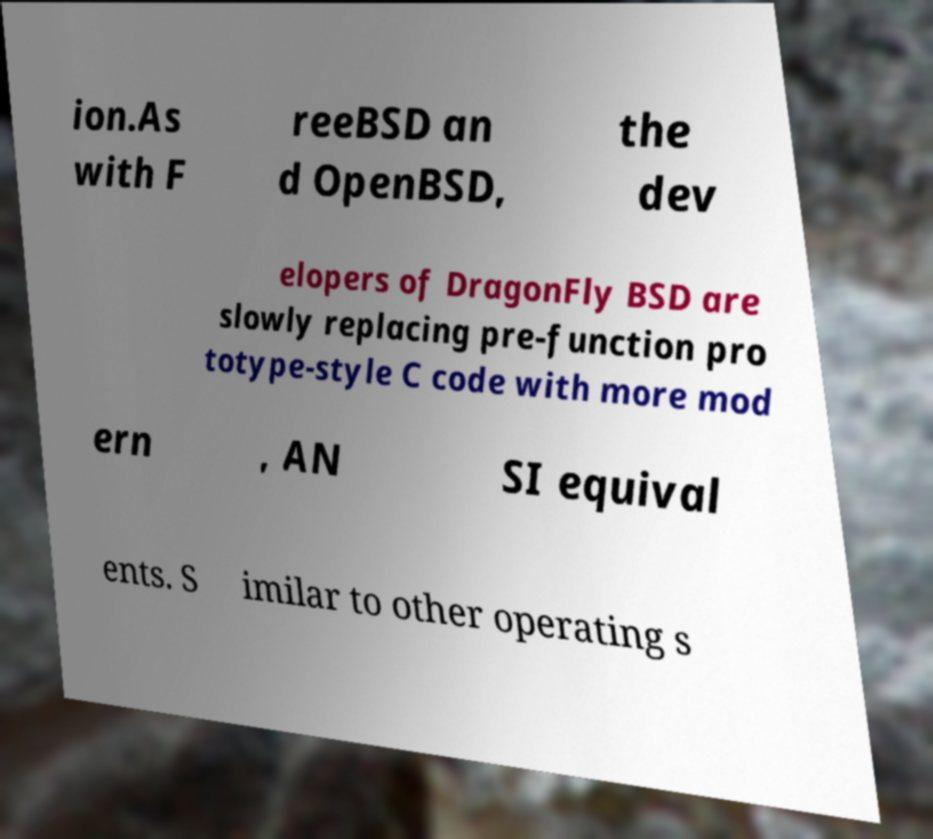Could you extract and type out the text from this image? ion.As with F reeBSD an d OpenBSD, the dev elopers of DragonFly BSD are slowly replacing pre-function pro totype-style C code with more mod ern , AN SI equival ents. S imilar to other operating s 